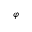Convert formula to latex. <formula><loc_0><loc_0><loc_500><loc_500>\varphi</formula> 